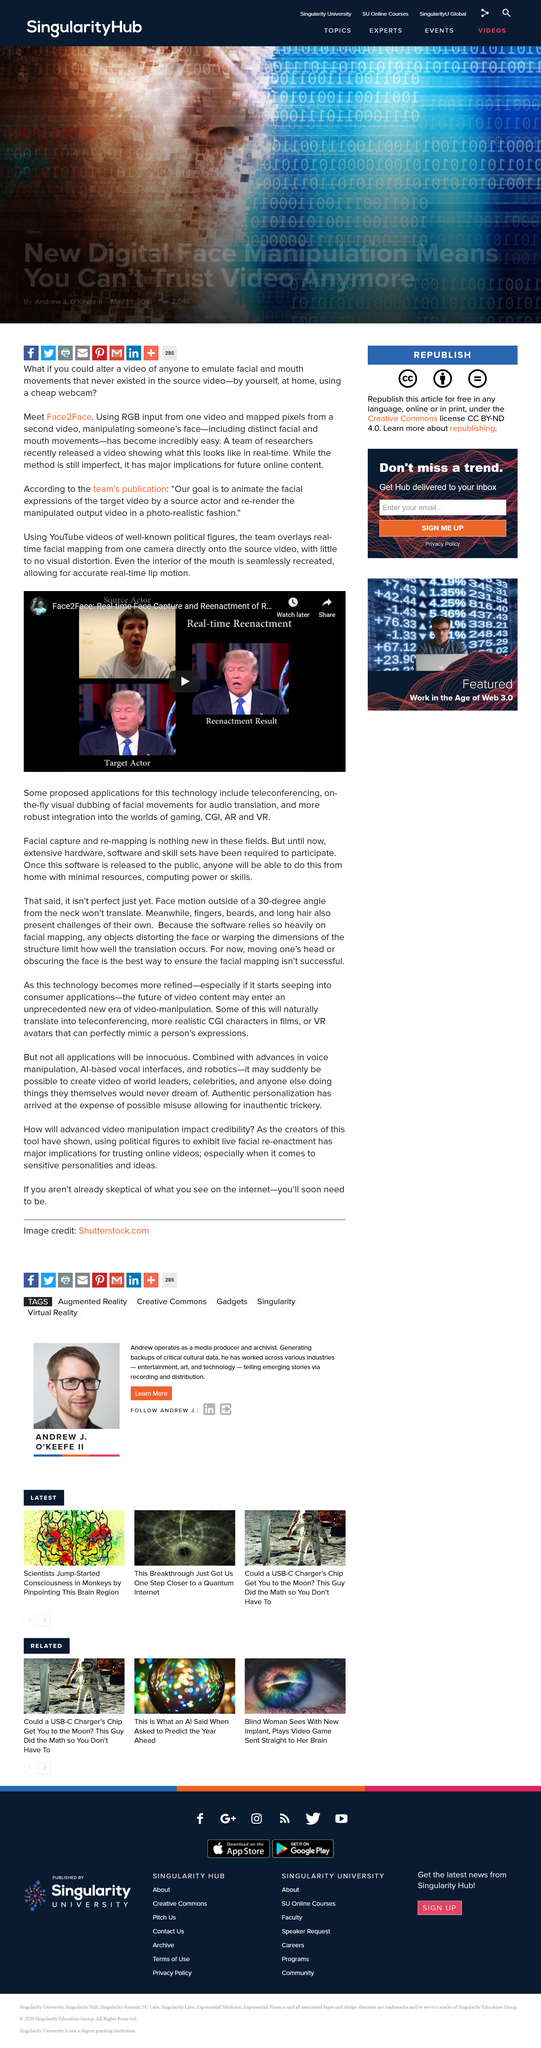Specify some key components in this picture. RGB input from one video is used to manipulate someone's face by mapping pixels from a second video, resulting in a controlled and altered visual representation of the subject's face. The interior of the mouth is seamlessly recreated in the 3D model. Face2Face is a technology that is used to overlay real-time facial mapping from one camera onto a YouTube video, effectively superimposing the source video's facial features onto the live video feed from the other camera. 